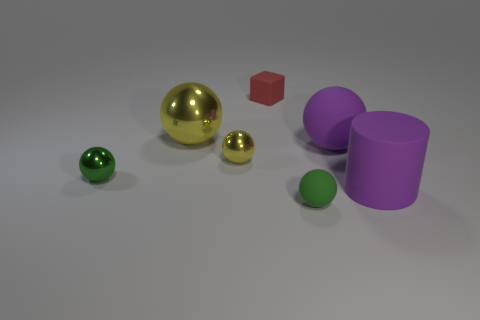Subtract all purple balls. How many balls are left? 4 Subtract all big purple rubber balls. How many balls are left? 4 Subtract all blue balls. Subtract all red cylinders. How many balls are left? 5 Add 3 tiny gray cylinders. How many objects exist? 10 Subtract all balls. How many objects are left? 2 Add 6 tiny red matte cubes. How many tiny red matte cubes are left? 7 Add 6 big cylinders. How many big cylinders exist? 7 Subtract 0 gray cylinders. How many objects are left? 7 Subtract all small rubber blocks. Subtract all tiny green objects. How many objects are left? 4 